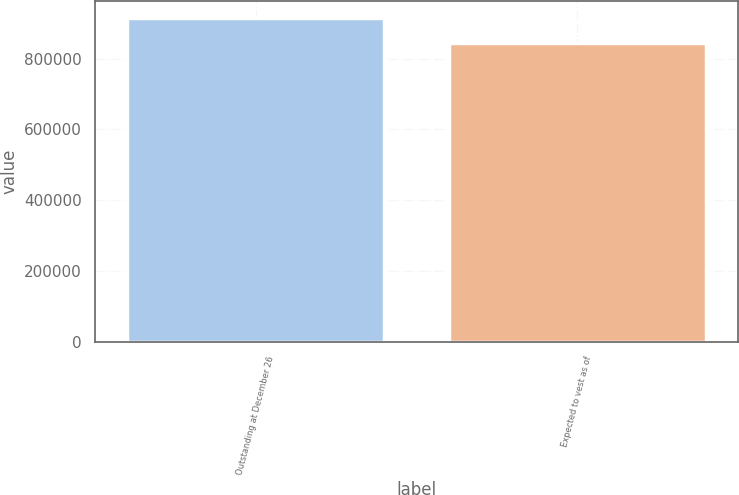<chart> <loc_0><loc_0><loc_500><loc_500><bar_chart><fcel>Outstanding at December 26<fcel>Expected to vest as of<nl><fcel>915727<fcel>843472<nl></chart> 